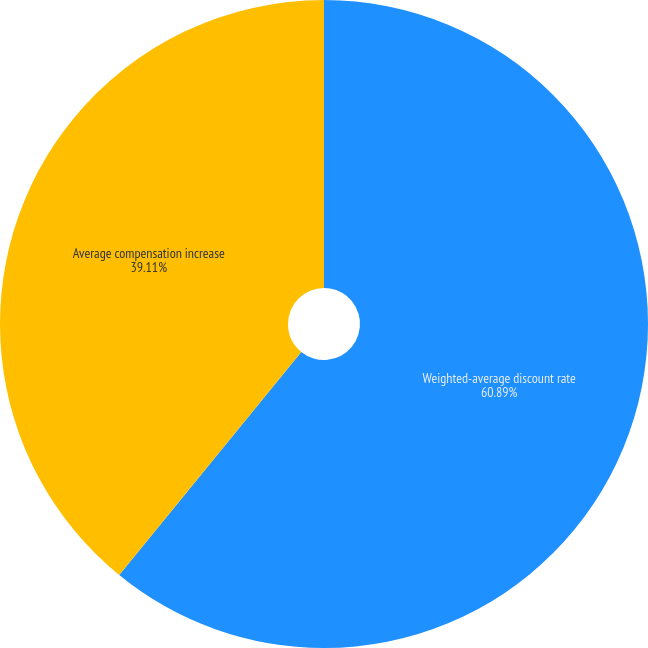<chart> <loc_0><loc_0><loc_500><loc_500><pie_chart><fcel>Weighted-average discount rate<fcel>Average compensation increase<nl><fcel>60.89%<fcel>39.11%<nl></chart> 